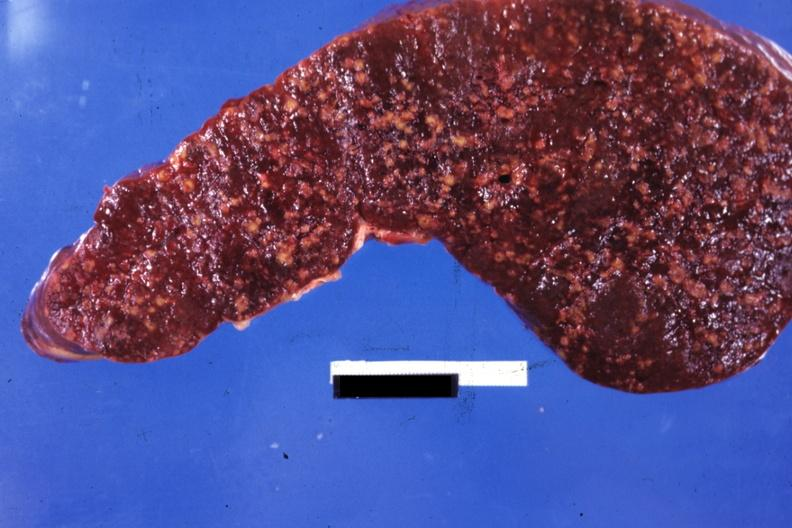s breast present?
Answer the question using a single word or phrase. No 